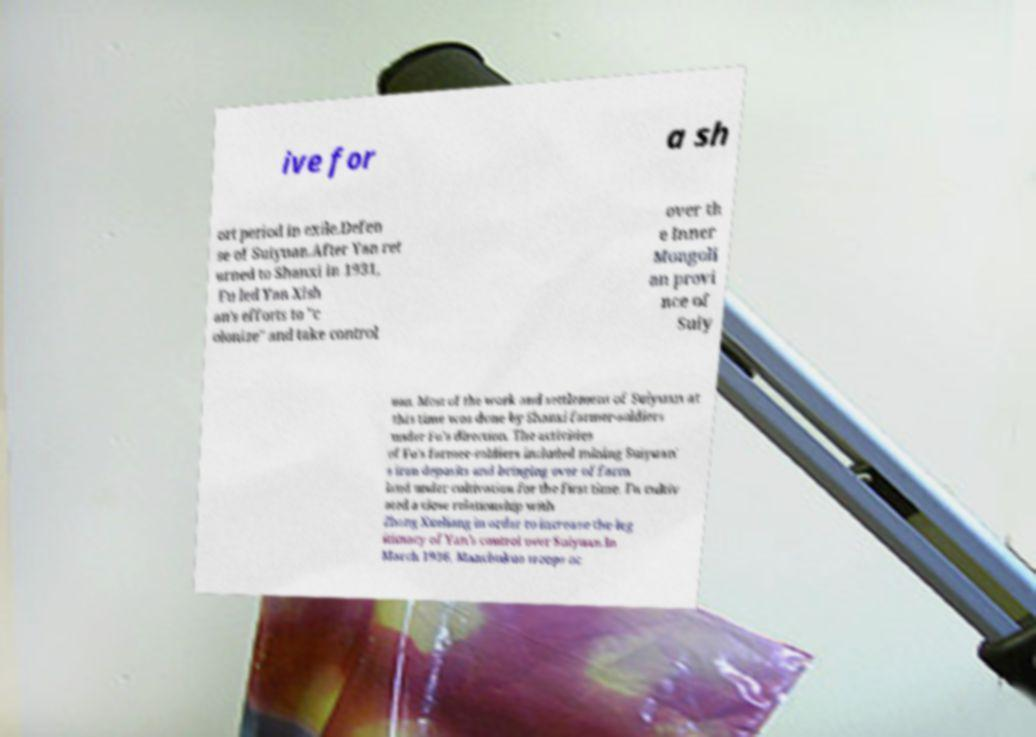Can you accurately transcribe the text from the provided image for me? ive for a sh ort period in exile.Defen se of Suiyuan.After Yan ret urned to Shanxi in 1931, Fu led Yan Xish an's efforts to "c olonize" and take control over th e Inner Mongoli an provi nce of Suiy uan. Most of the work and settlement of Suiyuan at this time was done by Shanxi farmer-soldiers under Fu's direction. The activities of Fu's farmer-soldiers included mining Suiyuan' s iron deposits and bringing over of farm land under cultivation for the first time. Fu cultiv ated a close relationship with Zhang Xueliang in order to increase the leg itimacy of Yan's control over Suiyuan.In March 1936, Manchukuo troops oc 